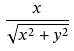<formula> <loc_0><loc_0><loc_500><loc_500>\frac { x } { \sqrt { x ^ { 2 } + y ^ { 2 } } }</formula> 